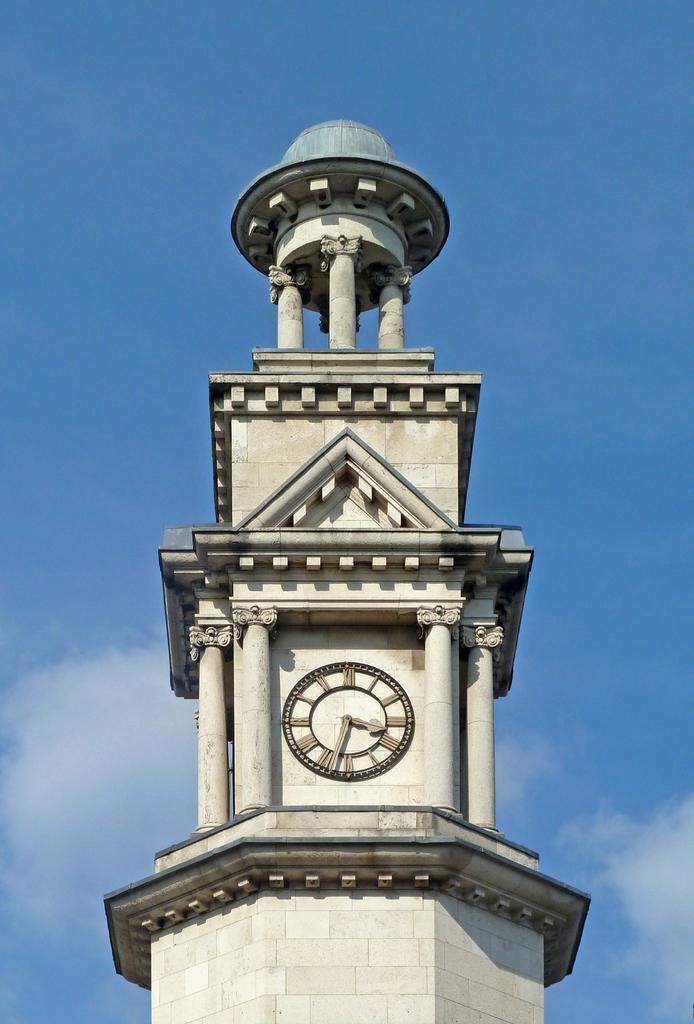<image>
Provide a brief description of the given image. Building with a clock that has the hands on numbers 3 and 7. 